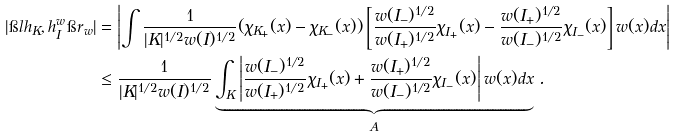Convert formula to latex. <formula><loc_0><loc_0><loc_500><loc_500>| \i l h _ { K } , h ^ { w } _ { I } \i r _ { w } | & = \left | \int \frac { 1 } { | K | ^ { 1 / 2 } w ( I ) ^ { 1 / 2 } } ( \chi _ { K _ { + } } ( x ) - \chi _ { K _ { - } } ( x ) ) \left [ \frac { w ( I _ { - } ) ^ { 1 / 2 } } { w ( I _ { + } ) ^ { 1 / 2 } } \chi _ { I _ { + } } ( x ) - \frac { w ( I _ { + } ) ^ { 1 / 2 } } { w ( I _ { - } ) ^ { 1 / 2 } } \chi _ { I _ { - } } ( x ) \right ] w ( x ) d x \right | \\ & \leq \frac { 1 } { | K | ^ { 1 / 2 } w ( I ) ^ { 1 / 2 } } \underbrace { \int _ { K } \left | \frac { w ( I _ { - } ) ^ { 1 / 2 } } { w ( I _ { + } ) ^ { 1 / 2 } } \chi _ { I _ { + } } ( x ) + \frac { w ( I _ { + } ) ^ { 1 / 2 } } { w ( I _ { - } ) ^ { 1 / 2 } } \chi _ { I _ { - } } ( x ) \right | w ( x ) d x } _ { A } \, .</formula> 